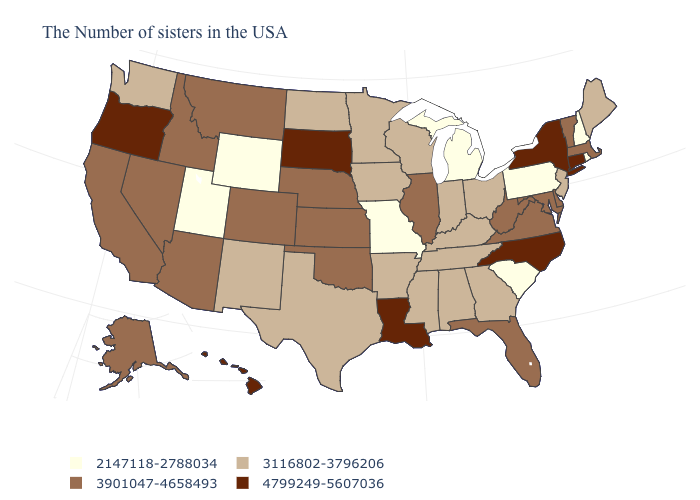Does New York have a higher value than Maine?
Answer briefly. Yes. What is the value of Georgia?
Keep it brief. 3116802-3796206. Among the states that border Connecticut , does Massachusetts have the lowest value?
Quick response, please. No. Does Kansas have a higher value than West Virginia?
Answer briefly. No. Among the states that border Kansas , which have the lowest value?
Short answer required. Missouri. Name the states that have a value in the range 2147118-2788034?
Short answer required. Rhode Island, New Hampshire, Pennsylvania, South Carolina, Michigan, Missouri, Wyoming, Utah. What is the value of Mississippi?
Quick response, please. 3116802-3796206. Does Wisconsin have the highest value in the USA?
Write a very short answer. No. Name the states that have a value in the range 4799249-5607036?
Quick response, please. Connecticut, New York, North Carolina, Louisiana, South Dakota, Oregon, Hawaii. Does Louisiana have the highest value in the USA?
Answer briefly. Yes. Does West Virginia have a higher value than Indiana?
Answer briefly. Yes. What is the highest value in the USA?
Quick response, please. 4799249-5607036. Which states have the highest value in the USA?
Be succinct. Connecticut, New York, North Carolina, Louisiana, South Dakota, Oregon, Hawaii. Name the states that have a value in the range 3116802-3796206?
Answer briefly. Maine, New Jersey, Ohio, Georgia, Kentucky, Indiana, Alabama, Tennessee, Wisconsin, Mississippi, Arkansas, Minnesota, Iowa, Texas, North Dakota, New Mexico, Washington. 